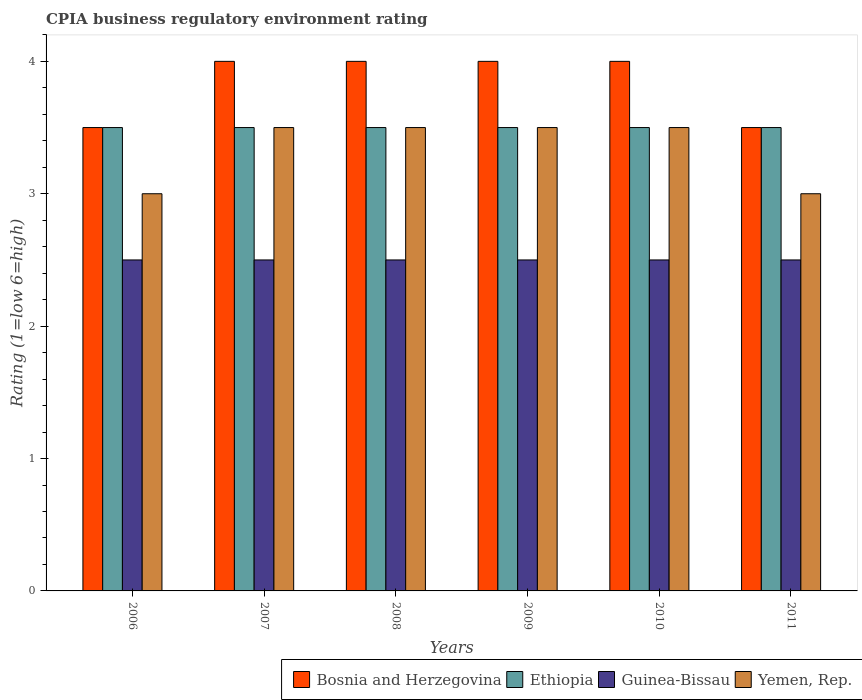How many different coloured bars are there?
Make the answer very short. 4. Are the number of bars per tick equal to the number of legend labels?
Offer a very short reply. Yes. Are the number of bars on each tick of the X-axis equal?
Keep it short and to the point. Yes. How many bars are there on the 3rd tick from the right?
Give a very brief answer. 4. In how many cases, is the number of bars for a given year not equal to the number of legend labels?
Offer a terse response. 0. Across all years, what is the maximum CPIA rating in Yemen, Rep.?
Ensure brevity in your answer.  3.5. Across all years, what is the minimum CPIA rating in Yemen, Rep.?
Offer a terse response. 3. In which year was the CPIA rating in Ethiopia maximum?
Provide a succinct answer. 2006. What is the total CPIA rating in Bosnia and Herzegovina in the graph?
Keep it short and to the point. 23. What is the average CPIA rating in Ethiopia per year?
Make the answer very short. 3.5. In the year 2007, what is the difference between the CPIA rating in Ethiopia and CPIA rating in Yemen, Rep.?
Ensure brevity in your answer.  0. In how many years, is the CPIA rating in Bosnia and Herzegovina greater than 0.4?
Offer a very short reply. 6. What is the ratio of the CPIA rating in Yemen, Rep. in 2007 to that in 2011?
Your response must be concise. 1.17. Is the CPIA rating in Ethiopia in 2008 less than that in 2011?
Your response must be concise. No. Is the difference between the CPIA rating in Ethiopia in 2009 and 2010 greater than the difference between the CPIA rating in Yemen, Rep. in 2009 and 2010?
Ensure brevity in your answer.  No. What is the difference between the highest and the second highest CPIA rating in Yemen, Rep.?
Offer a very short reply. 0. In how many years, is the CPIA rating in Yemen, Rep. greater than the average CPIA rating in Yemen, Rep. taken over all years?
Your answer should be very brief. 4. Is the sum of the CPIA rating in Bosnia and Herzegovina in 2007 and 2010 greater than the maximum CPIA rating in Yemen, Rep. across all years?
Keep it short and to the point. Yes. What does the 2nd bar from the left in 2006 represents?
Offer a terse response. Ethiopia. What does the 4th bar from the right in 2009 represents?
Ensure brevity in your answer.  Bosnia and Herzegovina. Are all the bars in the graph horizontal?
Offer a very short reply. No. How many years are there in the graph?
Your response must be concise. 6. Does the graph contain any zero values?
Your answer should be compact. No. Does the graph contain grids?
Provide a short and direct response. No. What is the title of the graph?
Your answer should be very brief. CPIA business regulatory environment rating. Does "Japan" appear as one of the legend labels in the graph?
Keep it short and to the point. No. What is the label or title of the X-axis?
Your answer should be very brief. Years. What is the Rating (1=low 6=high) of Ethiopia in 2006?
Make the answer very short. 3.5. What is the Rating (1=low 6=high) in Yemen, Rep. in 2006?
Your answer should be very brief. 3. What is the Rating (1=low 6=high) in Bosnia and Herzegovina in 2007?
Make the answer very short. 4. What is the Rating (1=low 6=high) in Ethiopia in 2007?
Provide a succinct answer. 3.5. What is the Rating (1=low 6=high) of Guinea-Bissau in 2007?
Ensure brevity in your answer.  2.5. What is the Rating (1=low 6=high) of Bosnia and Herzegovina in 2008?
Give a very brief answer. 4. What is the Rating (1=low 6=high) of Guinea-Bissau in 2009?
Offer a terse response. 2.5. What is the Rating (1=low 6=high) of Guinea-Bissau in 2011?
Your response must be concise. 2.5. What is the Rating (1=low 6=high) in Yemen, Rep. in 2011?
Keep it short and to the point. 3. Across all years, what is the maximum Rating (1=low 6=high) of Bosnia and Herzegovina?
Make the answer very short. 4. Across all years, what is the minimum Rating (1=low 6=high) of Yemen, Rep.?
Give a very brief answer. 3. What is the total Rating (1=low 6=high) in Bosnia and Herzegovina in the graph?
Your answer should be very brief. 23. What is the difference between the Rating (1=low 6=high) in Bosnia and Herzegovina in 2006 and that in 2007?
Your answer should be compact. -0.5. What is the difference between the Rating (1=low 6=high) in Ethiopia in 2006 and that in 2007?
Provide a short and direct response. 0. What is the difference between the Rating (1=low 6=high) in Guinea-Bissau in 2006 and that in 2007?
Give a very brief answer. 0. What is the difference between the Rating (1=low 6=high) of Yemen, Rep. in 2006 and that in 2007?
Provide a short and direct response. -0.5. What is the difference between the Rating (1=low 6=high) in Bosnia and Herzegovina in 2006 and that in 2008?
Your response must be concise. -0.5. What is the difference between the Rating (1=low 6=high) in Guinea-Bissau in 2006 and that in 2009?
Make the answer very short. 0. What is the difference between the Rating (1=low 6=high) in Guinea-Bissau in 2006 and that in 2010?
Offer a very short reply. 0. What is the difference between the Rating (1=low 6=high) of Ethiopia in 2006 and that in 2011?
Ensure brevity in your answer.  0. What is the difference between the Rating (1=low 6=high) of Ethiopia in 2007 and that in 2008?
Keep it short and to the point. 0. What is the difference between the Rating (1=low 6=high) of Guinea-Bissau in 2007 and that in 2008?
Ensure brevity in your answer.  0. What is the difference between the Rating (1=low 6=high) in Bosnia and Herzegovina in 2007 and that in 2009?
Provide a succinct answer. 0. What is the difference between the Rating (1=low 6=high) of Ethiopia in 2007 and that in 2009?
Ensure brevity in your answer.  0. What is the difference between the Rating (1=low 6=high) of Guinea-Bissau in 2007 and that in 2009?
Ensure brevity in your answer.  0. What is the difference between the Rating (1=low 6=high) of Yemen, Rep. in 2007 and that in 2009?
Your answer should be compact. 0. What is the difference between the Rating (1=low 6=high) of Bosnia and Herzegovina in 2008 and that in 2009?
Provide a succinct answer. 0. What is the difference between the Rating (1=low 6=high) of Guinea-Bissau in 2008 and that in 2009?
Ensure brevity in your answer.  0. What is the difference between the Rating (1=low 6=high) of Bosnia and Herzegovina in 2008 and that in 2010?
Give a very brief answer. 0. What is the difference between the Rating (1=low 6=high) in Bosnia and Herzegovina in 2008 and that in 2011?
Offer a very short reply. 0.5. What is the difference between the Rating (1=low 6=high) in Ethiopia in 2008 and that in 2011?
Make the answer very short. 0. What is the difference between the Rating (1=low 6=high) in Guinea-Bissau in 2008 and that in 2011?
Give a very brief answer. 0. What is the difference between the Rating (1=low 6=high) of Guinea-Bissau in 2009 and that in 2010?
Keep it short and to the point. 0. What is the difference between the Rating (1=low 6=high) in Ethiopia in 2009 and that in 2011?
Ensure brevity in your answer.  0. What is the difference between the Rating (1=low 6=high) of Bosnia and Herzegovina in 2010 and that in 2011?
Provide a short and direct response. 0.5. What is the difference between the Rating (1=low 6=high) of Yemen, Rep. in 2010 and that in 2011?
Your answer should be compact. 0.5. What is the difference between the Rating (1=low 6=high) in Bosnia and Herzegovina in 2006 and the Rating (1=low 6=high) in Ethiopia in 2007?
Make the answer very short. 0. What is the difference between the Rating (1=low 6=high) of Guinea-Bissau in 2006 and the Rating (1=low 6=high) of Yemen, Rep. in 2007?
Your answer should be very brief. -1. What is the difference between the Rating (1=low 6=high) in Bosnia and Herzegovina in 2006 and the Rating (1=low 6=high) in Guinea-Bissau in 2008?
Give a very brief answer. 1. What is the difference between the Rating (1=low 6=high) in Bosnia and Herzegovina in 2006 and the Rating (1=low 6=high) in Yemen, Rep. in 2008?
Make the answer very short. 0. What is the difference between the Rating (1=low 6=high) in Ethiopia in 2006 and the Rating (1=low 6=high) in Guinea-Bissau in 2008?
Your answer should be very brief. 1. What is the difference between the Rating (1=low 6=high) in Ethiopia in 2006 and the Rating (1=low 6=high) in Guinea-Bissau in 2009?
Ensure brevity in your answer.  1. What is the difference between the Rating (1=low 6=high) of Ethiopia in 2006 and the Rating (1=low 6=high) of Yemen, Rep. in 2009?
Keep it short and to the point. 0. What is the difference between the Rating (1=low 6=high) in Bosnia and Herzegovina in 2006 and the Rating (1=low 6=high) in Ethiopia in 2010?
Ensure brevity in your answer.  0. What is the difference between the Rating (1=low 6=high) in Bosnia and Herzegovina in 2006 and the Rating (1=low 6=high) in Guinea-Bissau in 2010?
Make the answer very short. 1. What is the difference between the Rating (1=low 6=high) in Bosnia and Herzegovina in 2006 and the Rating (1=low 6=high) in Yemen, Rep. in 2011?
Your response must be concise. 0.5. What is the difference between the Rating (1=low 6=high) in Bosnia and Herzegovina in 2007 and the Rating (1=low 6=high) in Ethiopia in 2008?
Provide a short and direct response. 0.5. What is the difference between the Rating (1=low 6=high) of Bosnia and Herzegovina in 2007 and the Rating (1=low 6=high) of Guinea-Bissau in 2008?
Offer a very short reply. 1.5. What is the difference between the Rating (1=low 6=high) of Ethiopia in 2007 and the Rating (1=low 6=high) of Guinea-Bissau in 2008?
Offer a very short reply. 1. What is the difference between the Rating (1=low 6=high) of Ethiopia in 2007 and the Rating (1=low 6=high) of Yemen, Rep. in 2008?
Give a very brief answer. 0. What is the difference between the Rating (1=low 6=high) of Bosnia and Herzegovina in 2007 and the Rating (1=low 6=high) of Ethiopia in 2009?
Offer a very short reply. 0.5. What is the difference between the Rating (1=low 6=high) of Bosnia and Herzegovina in 2007 and the Rating (1=low 6=high) of Guinea-Bissau in 2009?
Your answer should be compact. 1.5. What is the difference between the Rating (1=low 6=high) of Bosnia and Herzegovina in 2007 and the Rating (1=low 6=high) of Yemen, Rep. in 2009?
Give a very brief answer. 0.5. What is the difference between the Rating (1=low 6=high) in Ethiopia in 2007 and the Rating (1=low 6=high) in Yemen, Rep. in 2009?
Give a very brief answer. 0. What is the difference between the Rating (1=low 6=high) of Bosnia and Herzegovina in 2007 and the Rating (1=low 6=high) of Guinea-Bissau in 2010?
Keep it short and to the point. 1.5. What is the difference between the Rating (1=low 6=high) of Ethiopia in 2007 and the Rating (1=low 6=high) of Guinea-Bissau in 2010?
Make the answer very short. 1. What is the difference between the Rating (1=low 6=high) of Ethiopia in 2007 and the Rating (1=low 6=high) of Yemen, Rep. in 2010?
Your answer should be very brief. 0. What is the difference between the Rating (1=low 6=high) of Bosnia and Herzegovina in 2007 and the Rating (1=low 6=high) of Ethiopia in 2011?
Your answer should be very brief. 0.5. What is the difference between the Rating (1=low 6=high) of Bosnia and Herzegovina in 2007 and the Rating (1=low 6=high) of Yemen, Rep. in 2011?
Offer a terse response. 1. What is the difference between the Rating (1=low 6=high) in Ethiopia in 2007 and the Rating (1=low 6=high) in Yemen, Rep. in 2011?
Ensure brevity in your answer.  0.5. What is the difference between the Rating (1=low 6=high) of Guinea-Bissau in 2007 and the Rating (1=low 6=high) of Yemen, Rep. in 2011?
Keep it short and to the point. -0.5. What is the difference between the Rating (1=low 6=high) of Bosnia and Herzegovina in 2008 and the Rating (1=low 6=high) of Ethiopia in 2009?
Ensure brevity in your answer.  0.5. What is the difference between the Rating (1=low 6=high) in Ethiopia in 2008 and the Rating (1=low 6=high) in Guinea-Bissau in 2009?
Ensure brevity in your answer.  1. What is the difference between the Rating (1=low 6=high) of Ethiopia in 2008 and the Rating (1=low 6=high) of Yemen, Rep. in 2009?
Your response must be concise. 0. What is the difference between the Rating (1=low 6=high) in Guinea-Bissau in 2008 and the Rating (1=low 6=high) in Yemen, Rep. in 2009?
Keep it short and to the point. -1. What is the difference between the Rating (1=low 6=high) in Bosnia and Herzegovina in 2008 and the Rating (1=low 6=high) in Ethiopia in 2010?
Provide a succinct answer. 0.5. What is the difference between the Rating (1=low 6=high) in Ethiopia in 2008 and the Rating (1=low 6=high) in Guinea-Bissau in 2010?
Your answer should be very brief. 1. What is the difference between the Rating (1=low 6=high) in Ethiopia in 2008 and the Rating (1=low 6=high) in Yemen, Rep. in 2010?
Offer a very short reply. 0. What is the difference between the Rating (1=low 6=high) of Bosnia and Herzegovina in 2008 and the Rating (1=low 6=high) of Ethiopia in 2011?
Give a very brief answer. 0.5. What is the difference between the Rating (1=low 6=high) of Ethiopia in 2008 and the Rating (1=low 6=high) of Yemen, Rep. in 2011?
Make the answer very short. 0.5. What is the difference between the Rating (1=low 6=high) in Guinea-Bissau in 2008 and the Rating (1=low 6=high) in Yemen, Rep. in 2011?
Your response must be concise. -0.5. What is the difference between the Rating (1=low 6=high) in Bosnia and Herzegovina in 2009 and the Rating (1=low 6=high) in Ethiopia in 2010?
Your response must be concise. 0.5. What is the difference between the Rating (1=low 6=high) of Ethiopia in 2009 and the Rating (1=low 6=high) of Yemen, Rep. in 2010?
Provide a short and direct response. 0. What is the difference between the Rating (1=low 6=high) of Guinea-Bissau in 2009 and the Rating (1=low 6=high) of Yemen, Rep. in 2010?
Provide a succinct answer. -1. What is the difference between the Rating (1=low 6=high) of Bosnia and Herzegovina in 2009 and the Rating (1=low 6=high) of Guinea-Bissau in 2011?
Provide a succinct answer. 1.5. What is the difference between the Rating (1=low 6=high) of Guinea-Bissau in 2009 and the Rating (1=low 6=high) of Yemen, Rep. in 2011?
Make the answer very short. -0.5. What is the difference between the Rating (1=low 6=high) of Bosnia and Herzegovina in 2010 and the Rating (1=low 6=high) of Yemen, Rep. in 2011?
Offer a very short reply. 1. What is the difference between the Rating (1=low 6=high) of Guinea-Bissau in 2010 and the Rating (1=low 6=high) of Yemen, Rep. in 2011?
Offer a very short reply. -0.5. What is the average Rating (1=low 6=high) in Bosnia and Herzegovina per year?
Keep it short and to the point. 3.83. What is the average Rating (1=low 6=high) of Guinea-Bissau per year?
Make the answer very short. 2.5. What is the average Rating (1=low 6=high) in Yemen, Rep. per year?
Keep it short and to the point. 3.33. In the year 2007, what is the difference between the Rating (1=low 6=high) in Bosnia and Herzegovina and Rating (1=low 6=high) in Yemen, Rep.?
Your answer should be very brief. 0.5. In the year 2007, what is the difference between the Rating (1=low 6=high) in Ethiopia and Rating (1=low 6=high) in Guinea-Bissau?
Provide a succinct answer. 1. In the year 2007, what is the difference between the Rating (1=low 6=high) of Ethiopia and Rating (1=low 6=high) of Yemen, Rep.?
Your answer should be compact. 0. In the year 2007, what is the difference between the Rating (1=low 6=high) in Guinea-Bissau and Rating (1=low 6=high) in Yemen, Rep.?
Offer a terse response. -1. In the year 2008, what is the difference between the Rating (1=low 6=high) in Bosnia and Herzegovina and Rating (1=low 6=high) in Guinea-Bissau?
Your response must be concise. 1.5. In the year 2008, what is the difference between the Rating (1=low 6=high) in Ethiopia and Rating (1=low 6=high) in Yemen, Rep.?
Make the answer very short. 0. In the year 2009, what is the difference between the Rating (1=low 6=high) of Bosnia and Herzegovina and Rating (1=low 6=high) of Yemen, Rep.?
Offer a very short reply. 0.5. In the year 2009, what is the difference between the Rating (1=low 6=high) in Ethiopia and Rating (1=low 6=high) in Guinea-Bissau?
Offer a very short reply. 1. In the year 2009, what is the difference between the Rating (1=low 6=high) of Guinea-Bissau and Rating (1=low 6=high) of Yemen, Rep.?
Provide a succinct answer. -1. In the year 2010, what is the difference between the Rating (1=low 6=high) in Bosnia and Herzegovina and Rating (1=low 6=high) in Ethiopia?
Offer a terse response. 0.5. In the year 2010, what is the difference between the Rating (1=low 6=high) of Bosnia and Herzegovina and Rating (1=low 6=high) of Yemen, Rep.?
Keep it short and to the point. 0.5. In the year 2010, what is the difference between the Rating (1=low 6=high) of Ethiopia and Rating (1=low 6=high) of Guinea-Bissau?
Your answer should be compact. 1. In the year 2010, what is the difference between the Rating (1=low 6=high) of Ethiopia and Rating (1=low 6=high) of Yemen, Rep.?
Keep it short and to the point. 0. In the year 2011, what is the difference between the Rating (1=low 6=high) of Bosnia and Herzegovina and Rating (1=low 6=high) of Guinea-Bissau?
Make the answer very short. 1. In the year 2011, what is the difference between the Rating (1=low 6=high) in Bosnia and Herzegovina and Rating (1=low 6=high) in Yemen, Rep.?
Offer a terse response. 0.5. In the year 2011, what is the difference between the Rating (1=low 6=high) in Ethiopia and Rating (1=low 6=high) in Guinea-Bissau?
Make the answer very short. 1. What is the ratio of the Rating (1=low 6=high) of Bosnia and Herzegovina in 2006 to that in 2007?
Ensure brevity in your answer.  0.88. What is the ratio of the Rating (1=low 6=high) of Yemen, Rep. in 2006 to that in 2007?
Give a very brief answer. 0.86. What is the ratio of the Rating (1=low 6=high) of Ethiopia in 2006 to that in 2008?
Your response must be concise. 1. What is the ratio of the Rating (1=low 6=high) of Bosnia and Herzegovina in 2006 to that in 2009?
Give a very brief answer. 0.88. What is the ratio of the Rating (1=low 6=high) in Yemen, Rep. in 2006 to that in 2009?
Your response must be concise. 0.86. What is the ratio of the Rating (1=low 6=high) of Ethiopia in 2006 to that in 2010?
Your answer should be very brief. 1. What is the ratio of the Rating (1=low 6=high) of Guinea-Bissau in 2007 to that in 2008?
Offer a terse response. 1. What is the ratio of the Rating (1=low 6=high) in Ethiopia in 2007 to that in 2009?
Keep it short and to the point. 1. What is the ratio of the Rating (1=low 6=high) in Guinea-Bissau in 2007 to that in 2009?
Your answer should be compact. 1. What is the ratio of the Rating (1=low 6=high) of Ethiopia in 2007 to that in 2010?
Provide a short and direct response. 1. What is the ratio of the Rating (1=low 6=high) of Guinea-Bissau in 2007 to that in 2010?
Give a very brief answer. 1. What is the ratio of the Rating (1=low 6=high) in Ethiopia in 2008 to that in 2010?
Keep it short and to the point. 1. What is the ratio of the Rating (1=low 6=high) of Guinea-Bissau in 2008 to that in 2010?
Your answer should be very brief. 1. What is the ratio of the Rating (1=low 6=high) of Yemen, Rep. in 2008 to that in 2010?
Provide a short and direct response. 1. What is the ratio of the Rating (1=low 6=high) in Bosnia and Herzegovina in 2008 to that in 2011?
Keep it short and to the point. 1.14. What is the ratio of the Rating (1=low 6=high) in Guinea-Bissau in 2008 to that in 2011?
Your response must be concise. 1. What is the ratio of the Rating (1=low 6=high) of Yemen, Rep. in 2008 to that in 2011?
Provide a succinct answer. 1.17. What is the ratio of the Rating (1=low 6=high) of Bosnia and Herzegovina in 2009 to that in 2010?
Ensure brevity in your answer.  1. What is the ratio of the Rating (1=low 6=high) in Bosnia and Herzegovina in 2009 to that in 2011?
Your answer should be very brief. 1.14. What is the ratio of the Rating (1=low 6=high) in Bosnia and Herzegovina in 2010 to that in 2011?
Provide a succinct answer. 1.14. What is the ratio of the Rating (1=low 6=high) in Ethiopia in 2010 to that in 2011?
Your response must be concise. 1. What is the difference between the highest and the second highest Rating (1=low 6=high) of Bosnia and Herzegovina?
Keep it short and to the point. 0. What is the difference between the highest and the lowest Rating (1=low 6=high) of Bosnia and Herzegovina?
Offer a terse response. 0.5. What is the difference between the highest and the lowest Rating (1=low 6=high) of Ethiopia?
Give a very brief answer. 0. What is the difference between the highest and the lowest Rating (1=low 6=high) of Guinea-Bissau?
Keep it short and to the point. 0. 